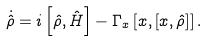Convert formula to latex. <formula><loc_0><loc_0><loc_500><loc_500>\dot { \hat { \rho } } = i \left [ \hat { \rho } , \hat { H } \right ] - \Gamma _ { x } \left [ \L x , \left [ \L x , \hat { \rho } \right ] \right ] .</formula> 